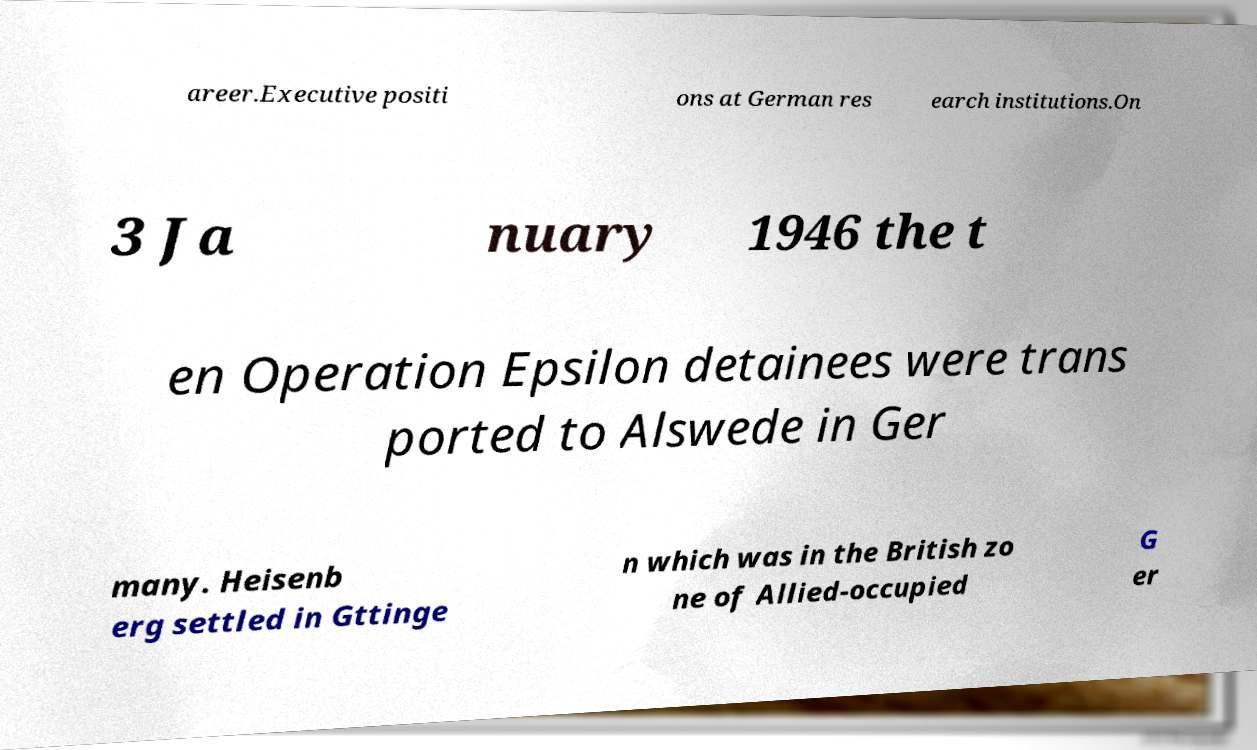Could you extract and type out the text from this image? areer.Executive positi ons at German res earch institutions.On 3 Ja nuary 1946 the t en Operation Epsilon detainees were trans ported to Alswede in Ger many. Heisenb erg settled in Gttinge n which was in the British zo ne of Allied-occupied G er 